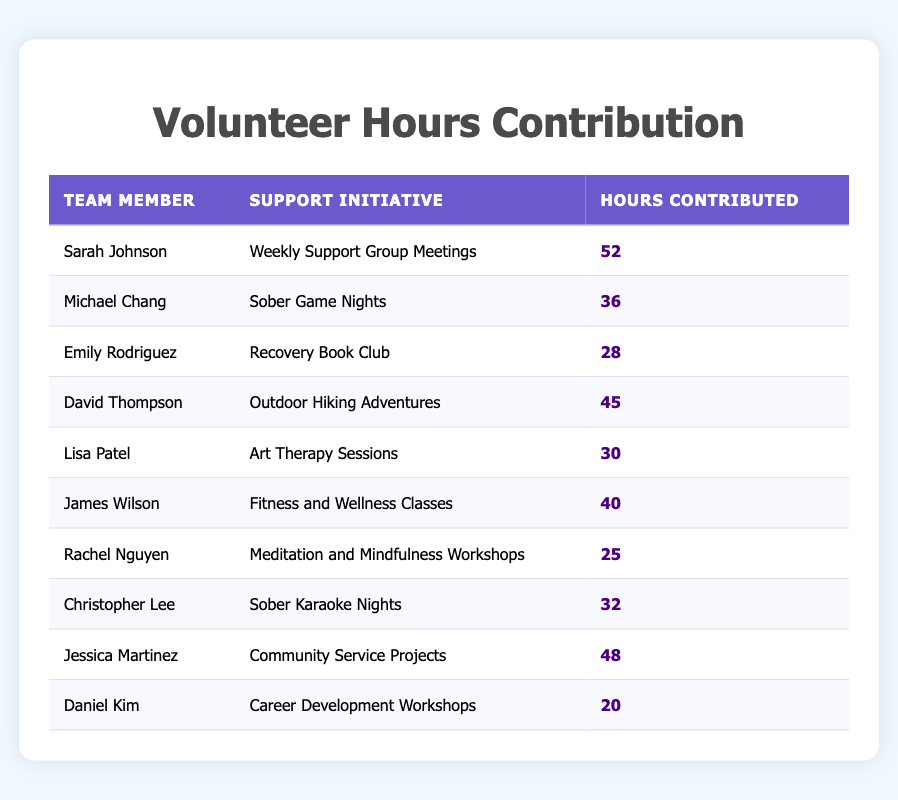What is the total number of hours contributed by Sarah Johnson? Sarah Johnson contributed 52 hours to the "Weekly Support Group Meetings" initiative.
Answer: 52 Which support initiative received the highest number of hours contributed? "Weekly Support Group Meetings" received the highest contribution of 52 hours by Sarah Johnson.
Answer: Weekly Support Group Meetings What is the average number of hours contributed by all team members? The total hours contributed are 52 + 36 + 28 + 45 + 30 + 40 + 25 + 32 + 48 + 20 = 386. There are 10 team members, so the average is 386 / 10 = 38.6.
Answer: 38.6 Is Lisa Patel one of the team members who contributed more than 30 hours? Lisa Patel contributed 30 hours, which is not more than 30 hours, so the answer is no.
Answer: No How many more hours did Jessica Martinez contribute compared to Daniel Kim? Jessica Martinez contributed 48 hours while Daniel Kim contributed 20 hours. The difference is 48 - 20 = 28 hours.
Answer: 28 What percentage of the total contributed hours were from David Thompson? David Thompson contributed 45 hours. The total hours contributed is 386, so the percentage is (45 / 386) * 100 ≈ 11.65%.
Answer: 11.65% Which two team members contributed the most hours combined in support initiatives? Sarah Johnson (52 hours) and Jessica Martinez (48 hours) contributed the most hours. Combined, they contributed 52 + 48 = 100 hours.
Answer: 100 Can you name a support initiative with less than 30 hours contributed? "Recovery Book Club" with 28 hours is the initiative that has less than 30 hours contributed.
Answer: Recovery Book Club What is the total number of hours contributed for the "Sober Game Nights" initiative? Michael Chang contributed a total of 36 hours for the "Sober Game Nights" initiative.
Answer: 36 